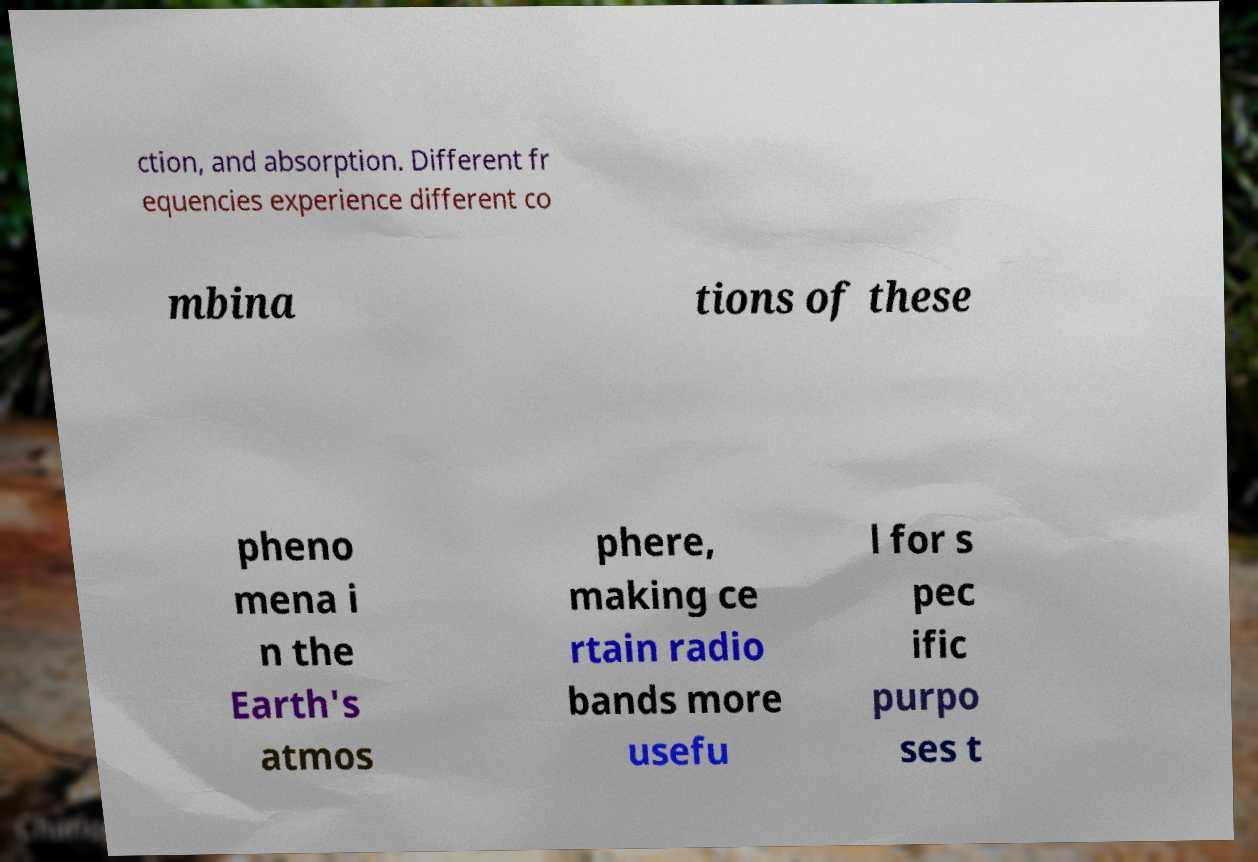Could you assist in decoding the text presented in this image and type it out clearly? ction, and absorption. Different fr equencies experience different co mbina tions of these pheno mena i n the Earth's atmos phere, making ce rtain radio bands more usefu l for s pec ific purpo ses t 